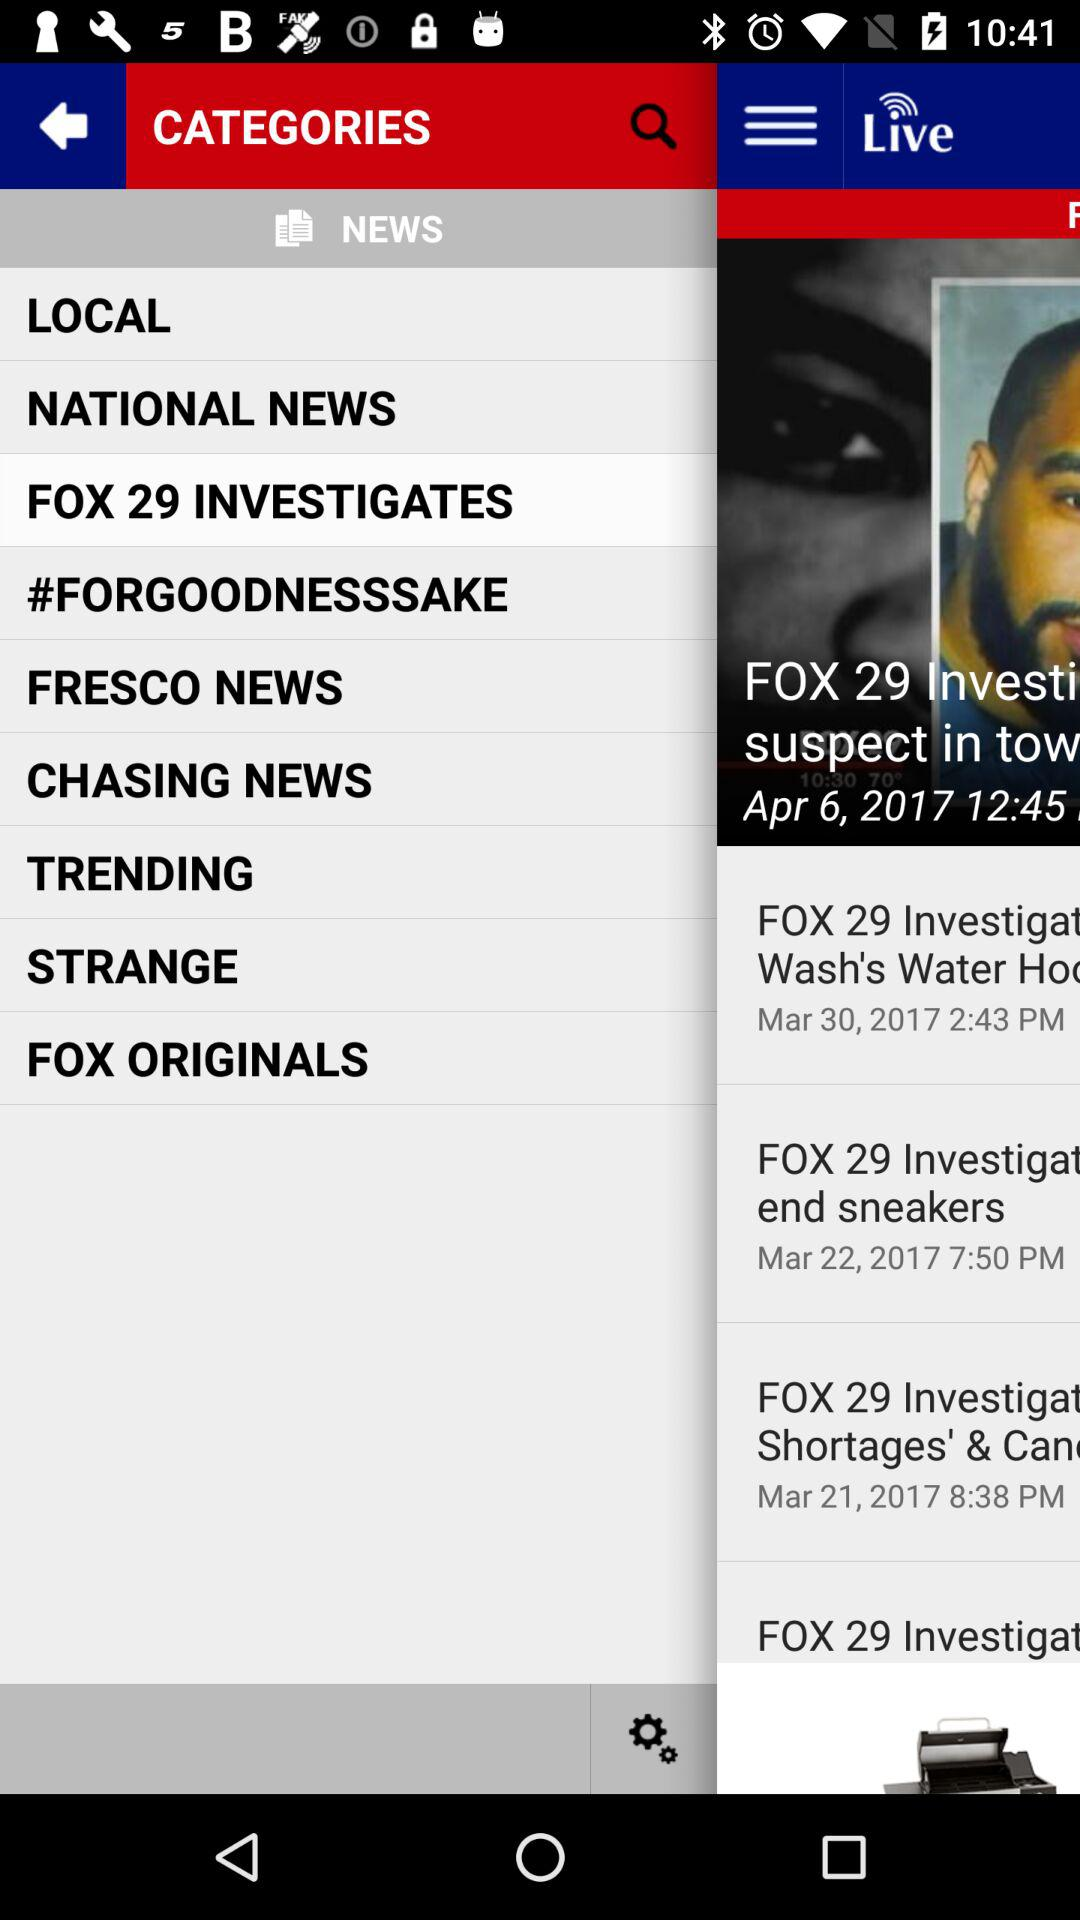When was "NEWS" last refreshed?
When the provided information is insufficient, respond with <no answer>. <no answer> 